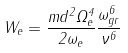Convert formula to latex. <formula><loc_0><loc_0><loc_500><loc_500>W _ { e } = \frac { m d ^ { 2 } \Omega _ { e } ^ { 4 } } { 2 \omega _ { e } } \frac { \omega _ { g r } ^ { 6 } } { \nu ^ { 6 } }</formula> 